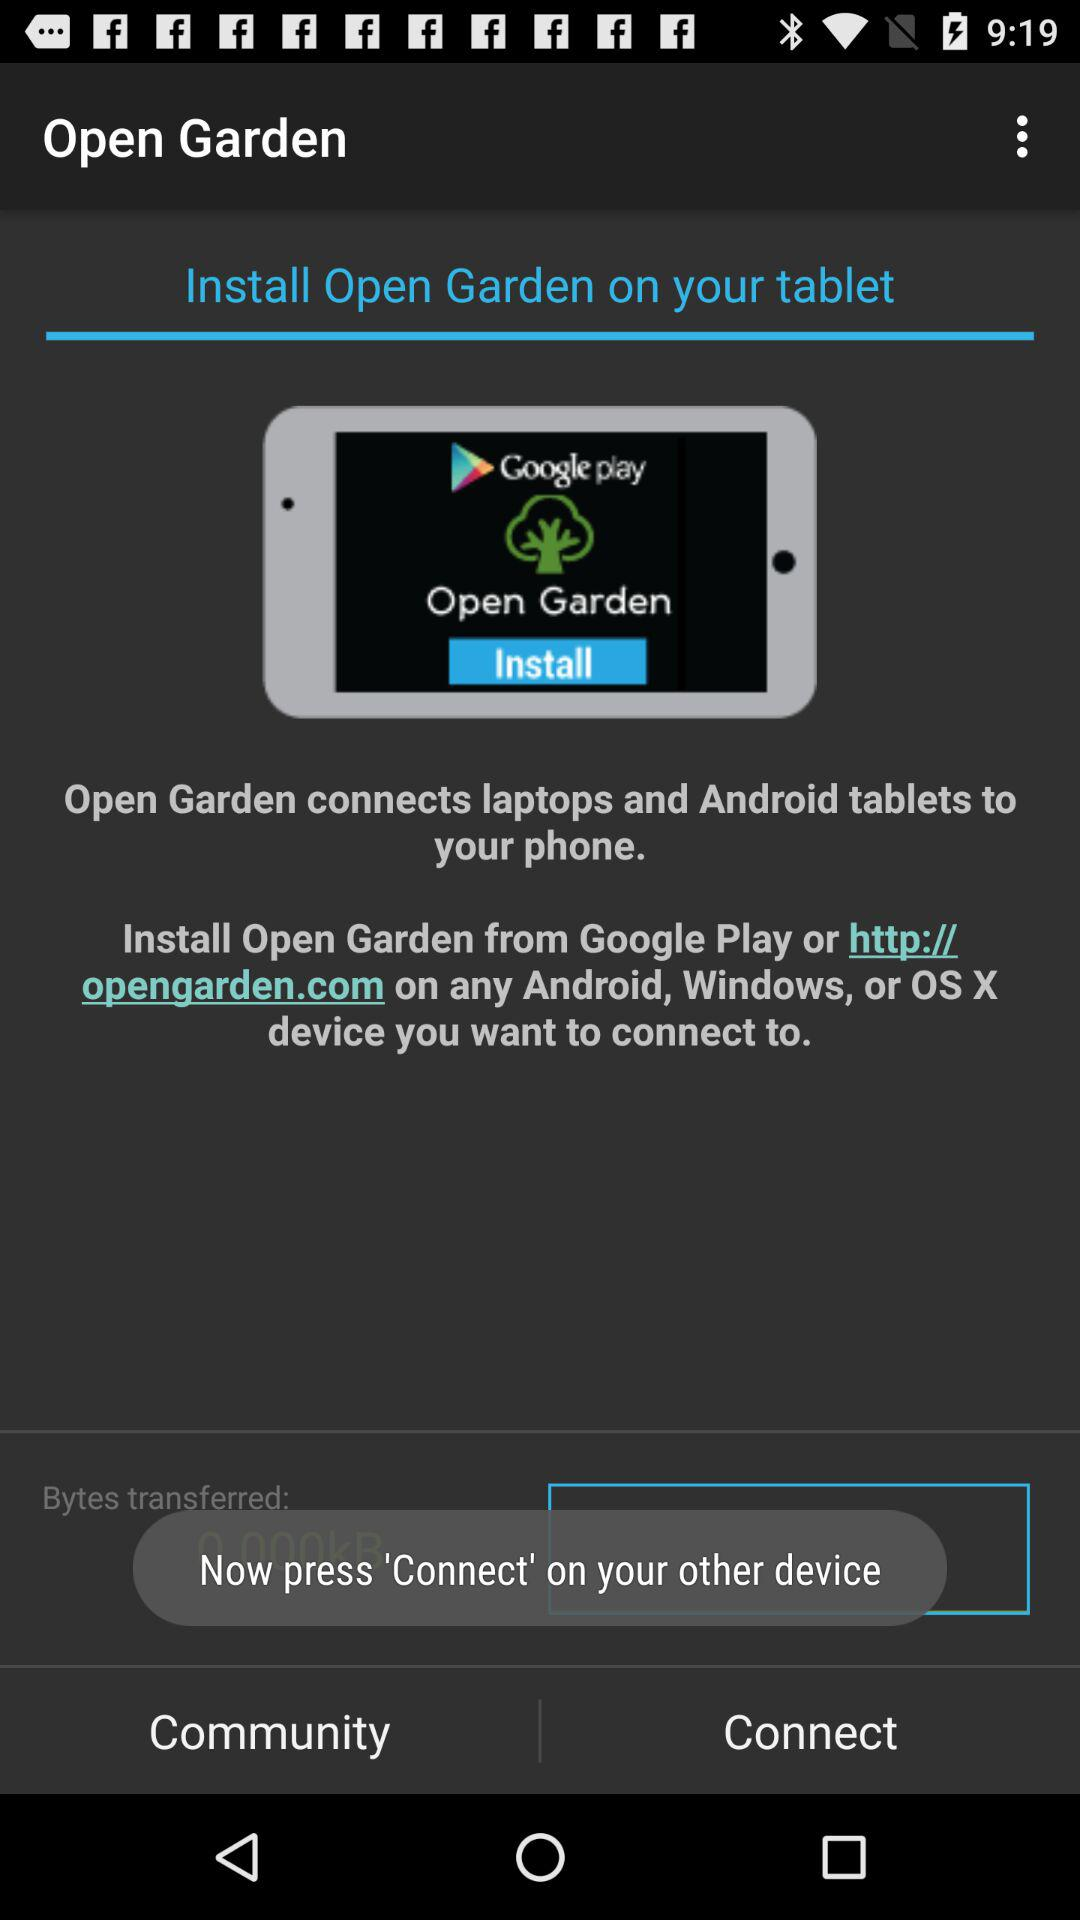What is the application name? The application name is "Open Garden". 